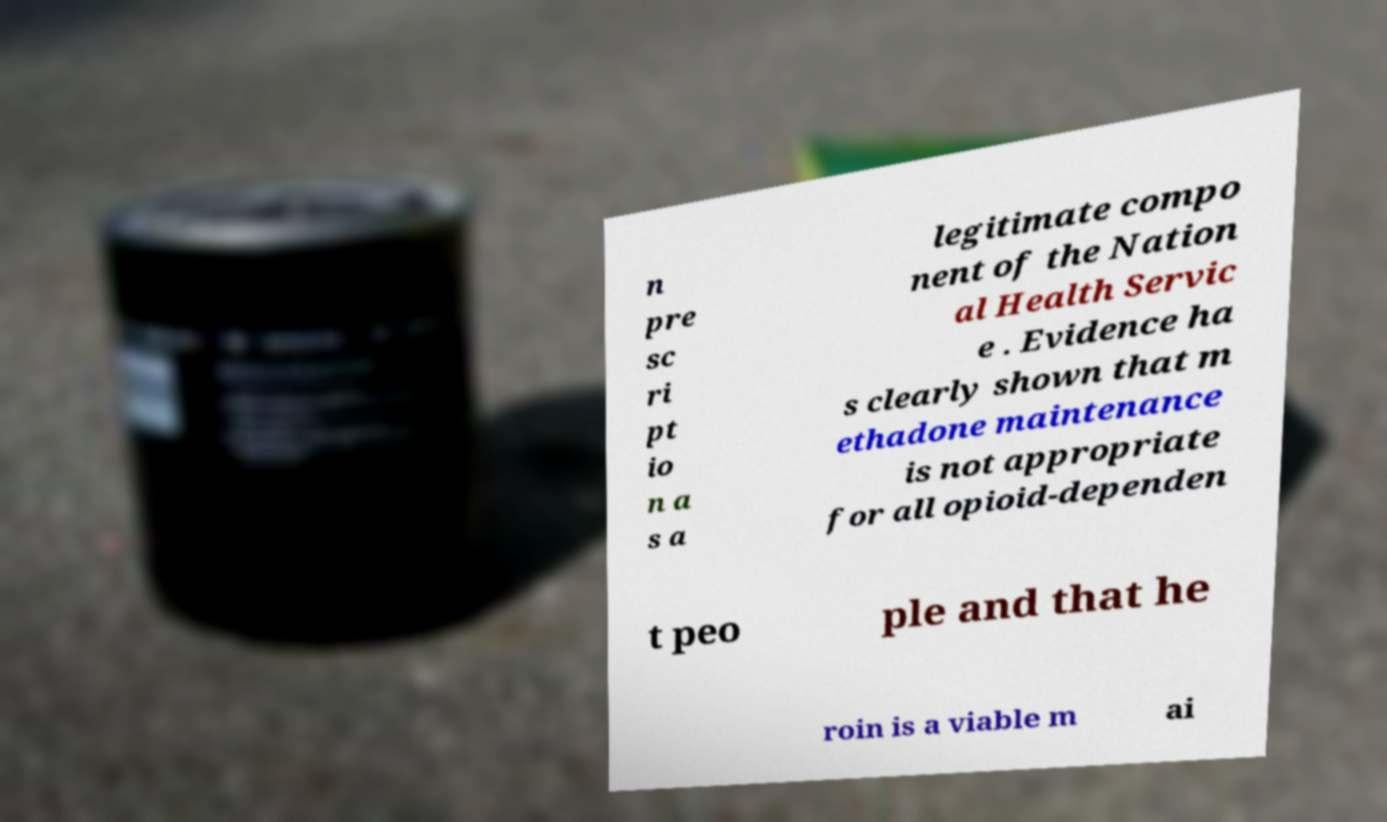I need the written content from this picture converted into text. Can you do that? n pre sc ri pt io n a s a legitimate compo nent of the Nation al Health Servic e . Evidence ha s clearly shown that m ethadone maintenance is not appropriate for all opioid-dependen t peo ple and that he roin is a viable m ai 